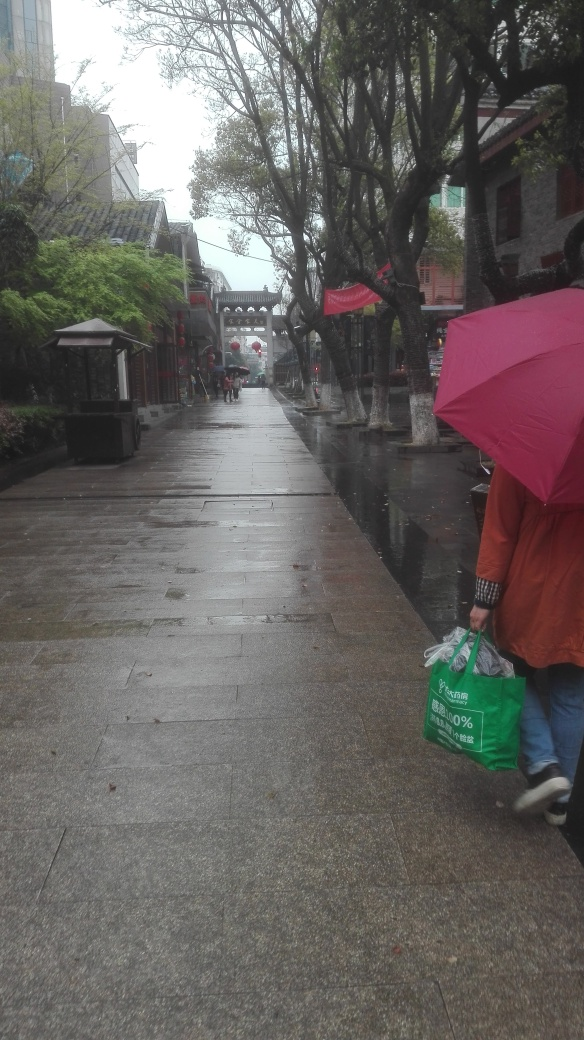What can you infer about the place from the image? The architecture of the buildings and the design of the street suggest a location with historical or cultural significance, possibly within an old town or a heritage district. The presence of hanging red lanterns could indicate that this place celebrates certain traditional festivities, and the gate structure in the distance is reminiscent of East Asian architectural styles. Do you think this place is usually more crowded? Why or why not? Given the thoughtful layout of the street and the presence of commercial signage, it's likely that this place would typically attract more foot traffic, perhaps as a shopping or tourist area. However, the current lack of crowds could be attributed to the rain dissuading people from spending time outdoors, or the photo could have been taken at a time of day when the area is less frequented. 